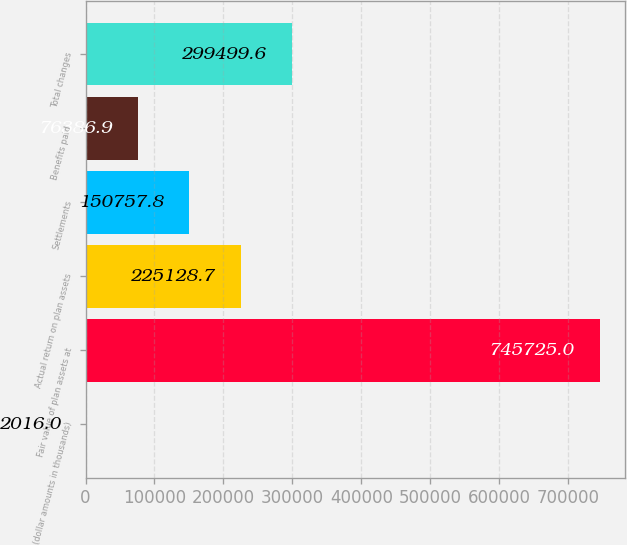<chart> <loc_0><loc_0><loc_500><loc_500><bar_chart><fcel>(dollar amounts in thousands)<fcel>Fair value of plan assets at<fcel>Actual return on plan assets<fcel>Settlements<fcel>Benefits paid<fcel>Total changes<nl><fcel>2016<fcel>745725<fcel>225129<fcel>150758<fcel>76386.9<fcel>299500<nl></chart> 